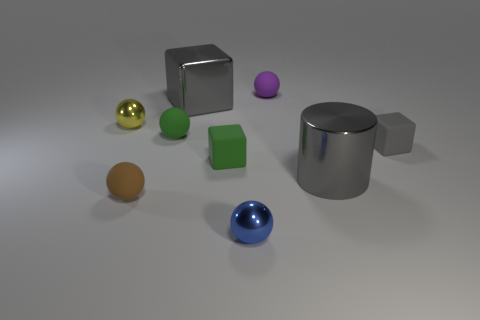Are there any small gray rubber objects that have the same shape as the brown rubber object?
Your answer should be compact. No. Do the shiny ball behind the tiny brown matte ball and the metallic ball in front of the gray metallic cylinder have the same size?
Give a very brief answer. Yes. The small green matte object behind the small gray rubber object that is to the right of the brown thing is what shape?
Offer a very short reply. Sphere. What number of purple things have the same size as the blue object?
Give a very brief answer. 1. Are any tiny purple rubber cylinders visible?
Your answer should be compact. No. Is there any other thing that has the same color as the large metal cube?
Offer a terse response. Yes. There is a gray thing that is made of the same material as the brown sphere; what shape is it?
Offer a terse response. Cube. There is a large metallic thing that is on the left side of the sphere behind the small metal sphere behind the gray rubber cube; what color is it?
Make the answer very short. Gray. Is the number of big metallic things on the right side of the big gray block the same as the number of purple rubber spheres?
Keep it short and to the point. Yes. There is a big cylinder; is its color the same as the tiny matte block that is right of the purple object?
Your answer should be very brief. Yes. 